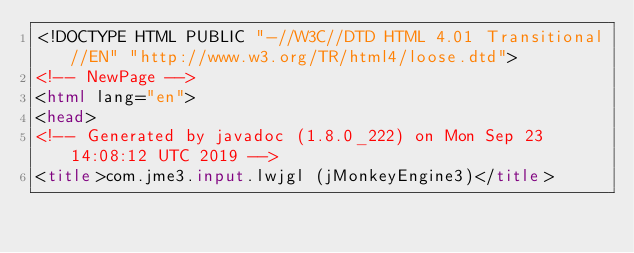<code> <loc_0><loc_0><loc_500><loc_500><_HTML_><!DOCTYPE HTML PUBLIC "-//W3C//DTD HTML 4.01 Transitional//EN" "http://www.w3.org/TR/html4/loose.dtd">
<!-- NewPage -->
<html lang="en">
<head>
<!-- Generated by javadoc (1.8.0_222) on Mon Sep 23 14:08:12 UTC 2019 -->
<title>com.jme3.input.lwjgl (jMonkeyEngine3)</title></code> 